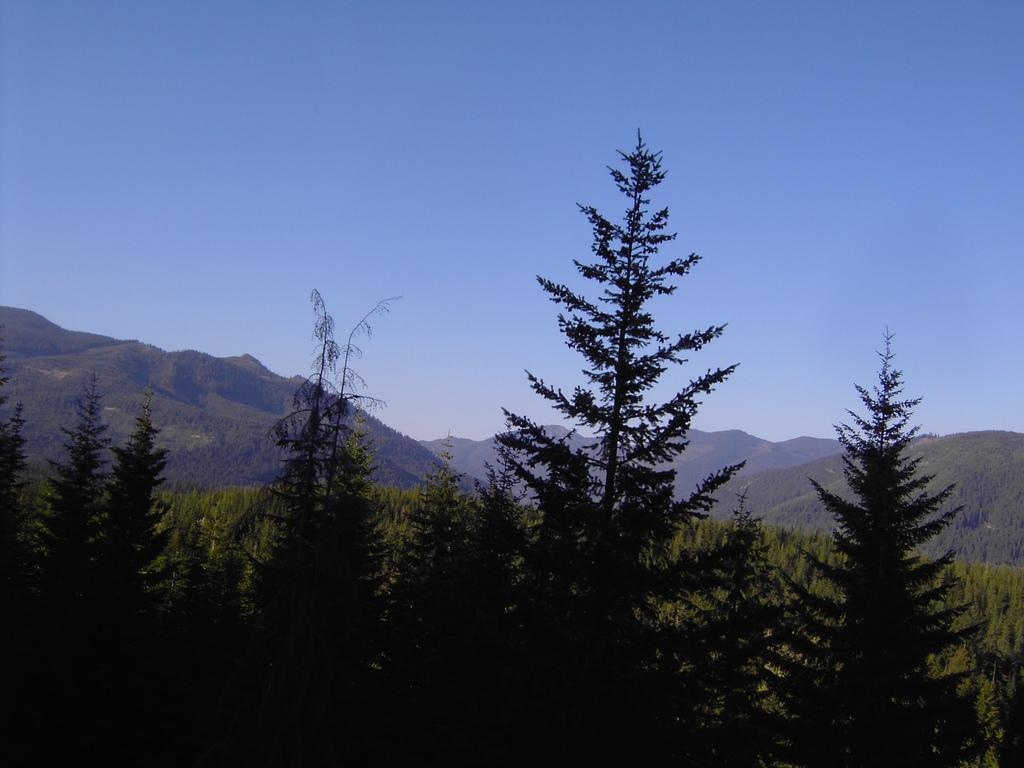What type of natural vegetation is visible in the image? There are trees in the image. What type of geological formation can be seen in the image? There are mountains in the image. Where is the judge located in the image? There is no judge present in the image. What type of activity is happening at the camp in the image? There is no camp present in the image. 